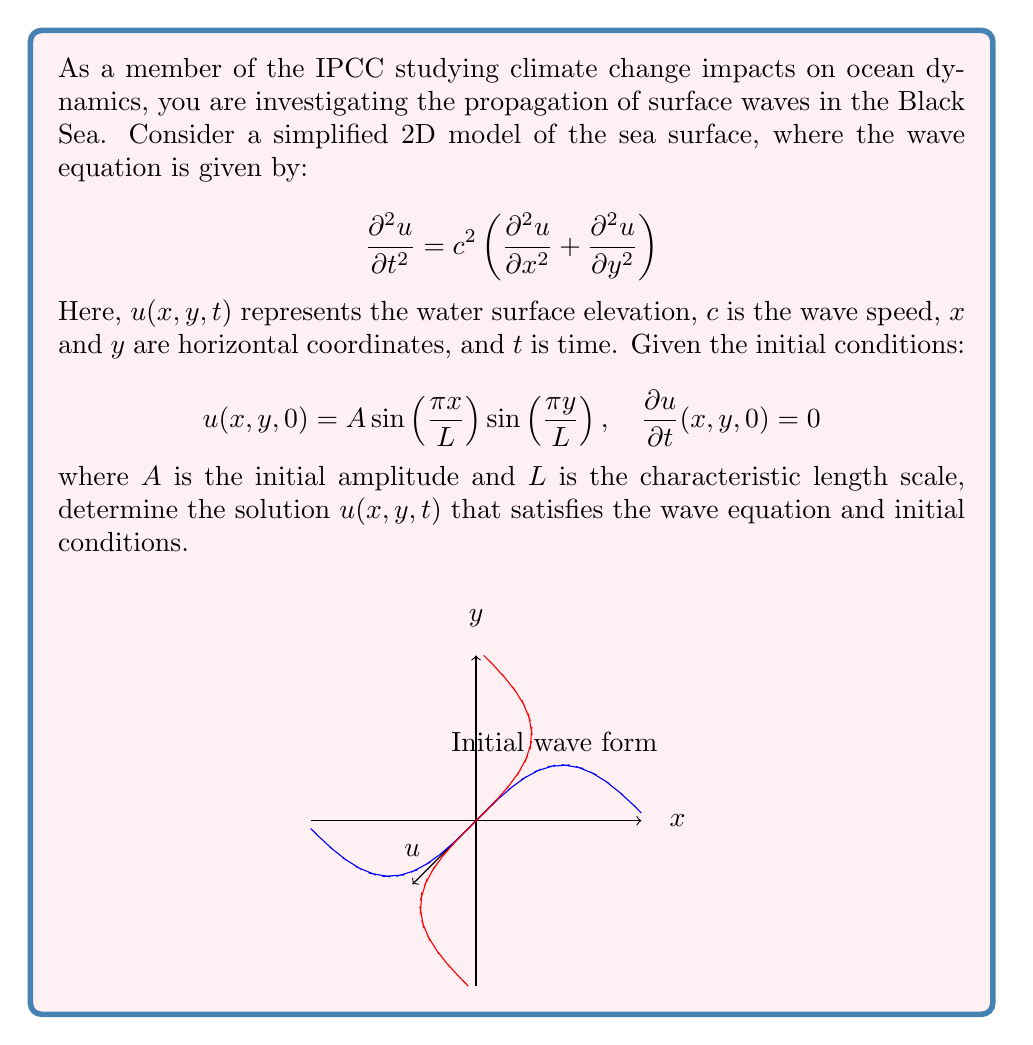Solve this math problem. To solve this problem, we'll follow these steps:

1) The general solution for the 2D wave equation with the given initial conditions takes the form:

   $$u(x,y,t) = f(x,y)\cos(\omega t)$$

   where $f(x,y)$ represents the spatial component and $\omega$ is the angular frequency.

2) From the initial condition $u(x,y,0) = A \sin(\frac{\pi x}{L}) \sin(\frac{\pi y}{L})$, we can deduce:

   $$f(x,y) = A \sin(\frac{\pi x}{L}) \sin(\frac{\pi y}{L})$$

3) To find $\omega$, we substitute the general solution into the wave equation:

   $$-\omega^2 f(x,y)\cos(\omega t) = c^2 \left(\frac{\partial^2 f}{\partial x^2} + \frac{\partial^2 f}{\partial y^2}\right)\cos(\omega t)$$

4) Simplifying and cancelling $\cos(\omega t)$:

   $$\omega^2 f(x,y) = -c^2 \left(\frac{\partial^2 f}{\partial x^2} + \frac{\partial^2 f}{\partial y^2}\right)$$

5) Computing the partial derivatives:

   $$\frac{\partial^2 f}{\partial x^2} = -\frac{\pi^2}{L^2}A \sin(\frac{\pi x}{L}) \sin(\frac{\pi y}{L})$$
   $$\frac{\partial^2 f}{\partial y^2} = -\frac{\pi^2}{L^2}A \sin(\frac{\pi x}{L}) \sin(\frac{\pi y}{L})$$

6) Substituting back:

   $$\omega^2 A \sin(\frac{\pi x}{L}) \sin(\frac{\pi y}{L}) = c^2 \left(\frac{2\pi^2}{L^2}\right)A \sin(\frac{\pi x}{L}) \sin(\frac{\pi y}{L})$$

7) Simplifying:

   $$\omega^2 = \frac{2\pi^2 c^2}{L^2}$$

   $$\omega = \frac{\sqrt{2}\pi c}{L}$$

8) Therefore, the complete solution is:

   $$u(x,y,t) = A \sin(\frac{\pi x}{L}) \sin(\frac{\pi y}{L}) \cos(\frac{\sqrt{2}\pi c}{L}t)$$

This solution satisfies both the wave equation and the initial conditions.
Answer: $$u(x,y,t) = A \sin(\frac{\pi x}{L}) \sin(\frac{\pi y}{L}) \cos(\frac{\sqrt{2}\pi c}{L}t)$$ 